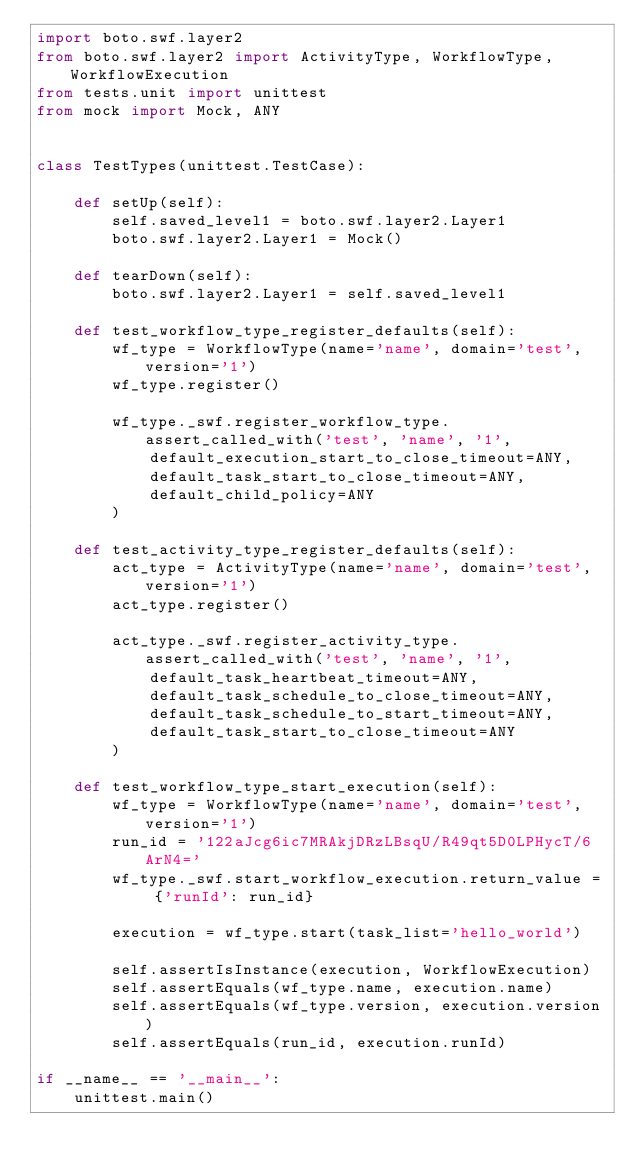Convert code to text. <code><loc_0><loc_0><loc_500><loc_500><_Python_>import boto.swf.layer2
from boto.swf.layer2 import ActivityType, WorkflowType, WorkflowExecution
from tests.unit import unittest
from mock import Mock, ANY


class TestTypes(unittest.TestCase):

    def setUp(self):
        self.saved_level1 = boto.swf.layer2.Layer1
        boto.swf.layer2.Layer1 = Mock()

    def tearDown(self):
        boto.swf.layer2.Layer1 = self.saved_level1
    
    def test_workflow_type_register_defaults(self):
        wf_type = WorkflowType(name='name', domain='test', version='1')
        wf_type.register()

        wf_type._swf.register_workflow_type.assert_called_with('test', 'name', '1',
            default_execution_start_to_close_timeout=ANY,    
            default_task_start_to_close_timeout=ANY,
            default_child_policy=ANY
        )

    def test_activity_type_register_defaults(self):
        act_type = ActivityType(name='name', domain='test', version='1')
        act_type.register()

        act_type._swf.register_activity_type.assert_called_with('test', 'name', '1',
            default_task_heartbeat_timeout=ANY,    
            default_task_schedule_to_close_timeout=ANY,
            default_task_schedule_to_start_timeout=ANY,
            default_task_start_to_close_timeout=ANY
        )

    def test_workflow_type_start_execution(self):
        wf_type = WorkflowType(name='name', domain='test', version='1')
        run_id = '122aJcg6ic7MRAkjDRzLBsqU/R49qt5D0LPHycT/6ArN4='
        wf_type._swf.start_workflow_execution.return_value = {'runId': run_id}
        
        execution = wf_type.start(task_list='hello_world')

        self.assertIsInstance(execution, WorkflowExecution)
        self.assertEquals(wf_type.name, execution.name)
        self.assertEquals(wf_type.version, execution.version)
        self.assertEquals(run_id, execution.runId)

if __name__ == '__main__':
    unittest.main()
</code> 